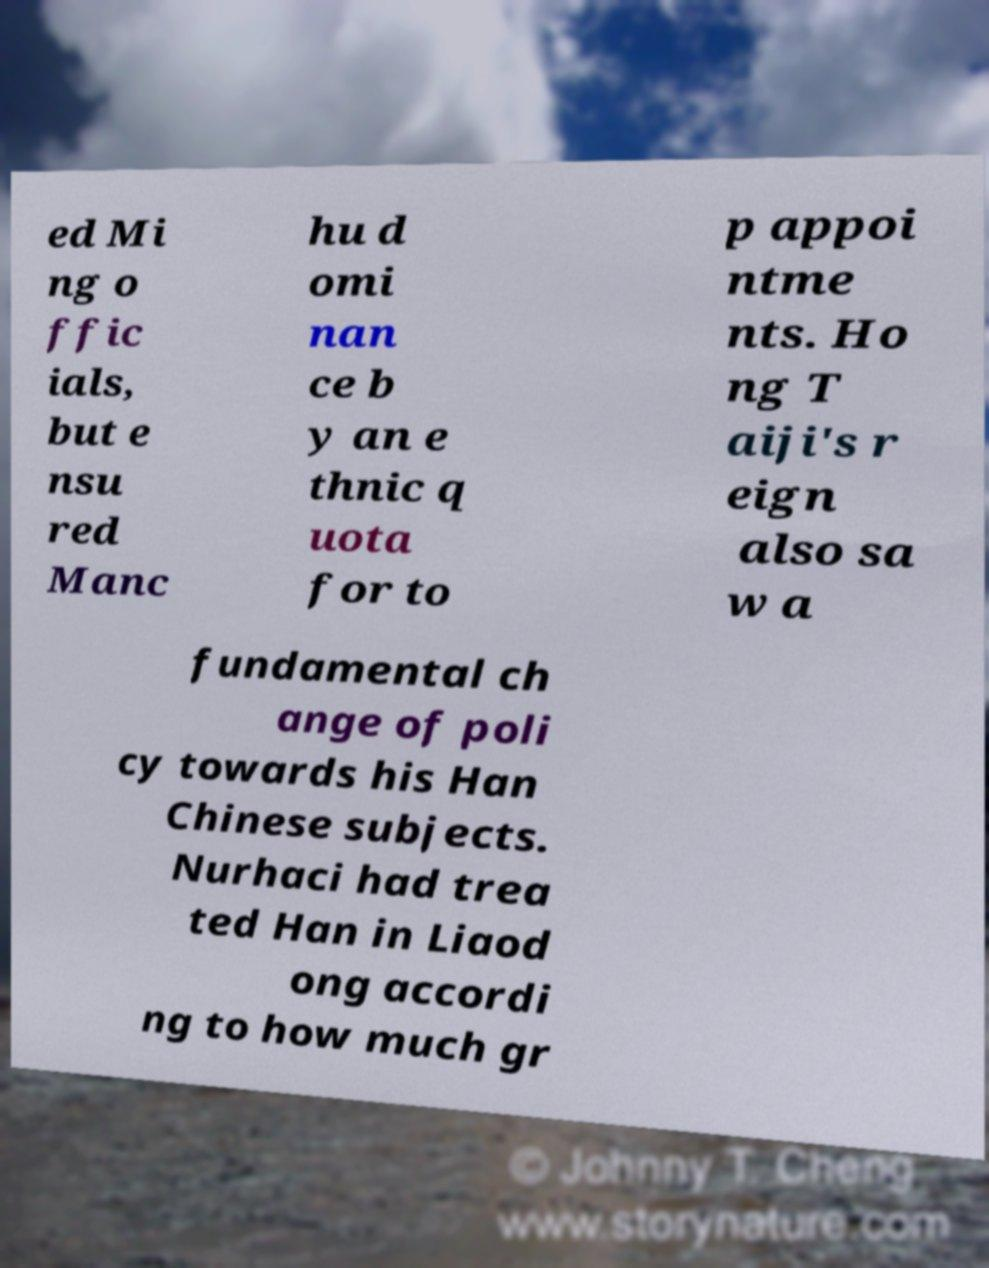For documentation purposes, I need the text within this image transcribed. Could you provide that? ed Mi ng o ffic ials, but e nsu red Manc hu d omi nan ce b y an e thnic q uota for to p appoi ntme nts. Ho ng T aiji's r eign also sa w a fundamental ch ange of poli cy towards his Han Chinese subjects. Nurhaci had trea ted Han in Liaod ong accordi ng to how much gr 